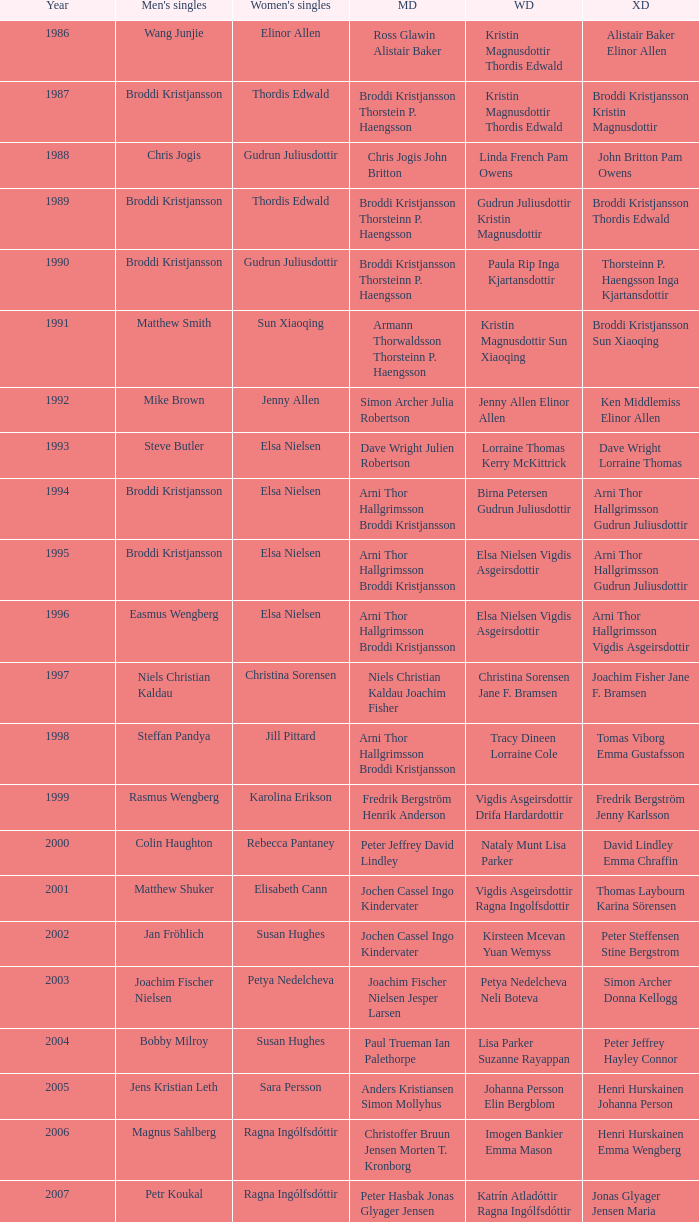In what mixed doubles did Niels Christian Kaldau play in men's singles? Joachim Fisher Jane F. Bramsen. 